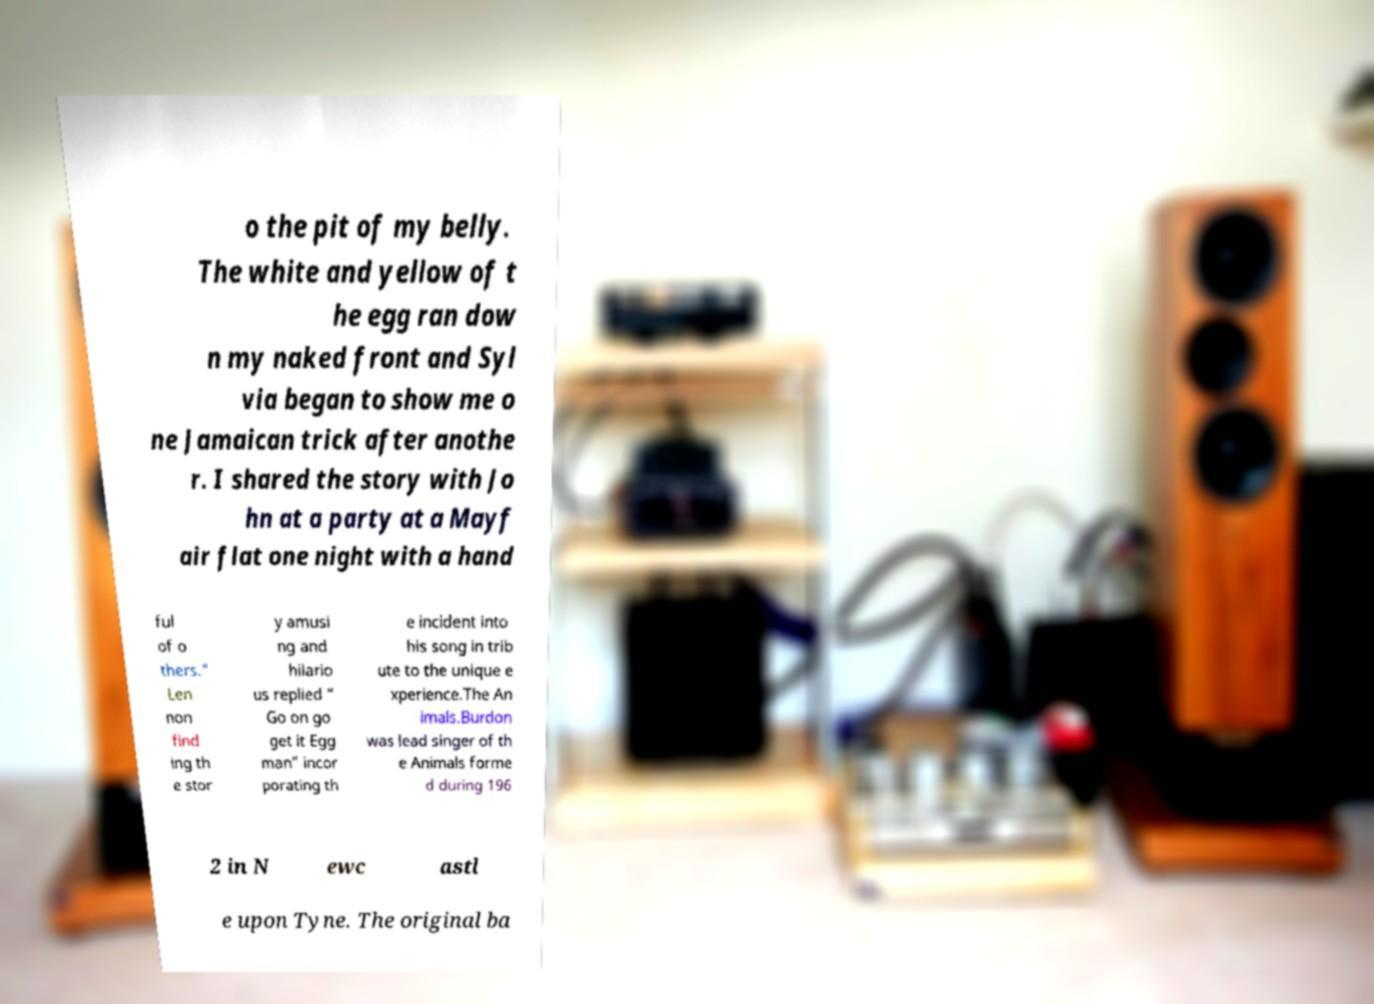Can you read and provide the text displayed in the image?This photo seems to have some interesting text. Can you extract and type it out for me? o the pit of my belly. The white and yellow of t he egg ran dow n my naked front and Syl via began to show me o ne Jamaican trick after anothe r. I shared the story with Jo hn at a party at a Mayf air flat one night with a hand ful of o thers." Len non find ing th e stor y amusi ng and hilario us replied “ Go on go get it Egg man” incor porating th e incident into his song in trib ute to the unique e xperience.The An imals.Burdon was lead singer of th e Animals forme d during 196 2 in N ewc astl e upon Tyne. The original ba 